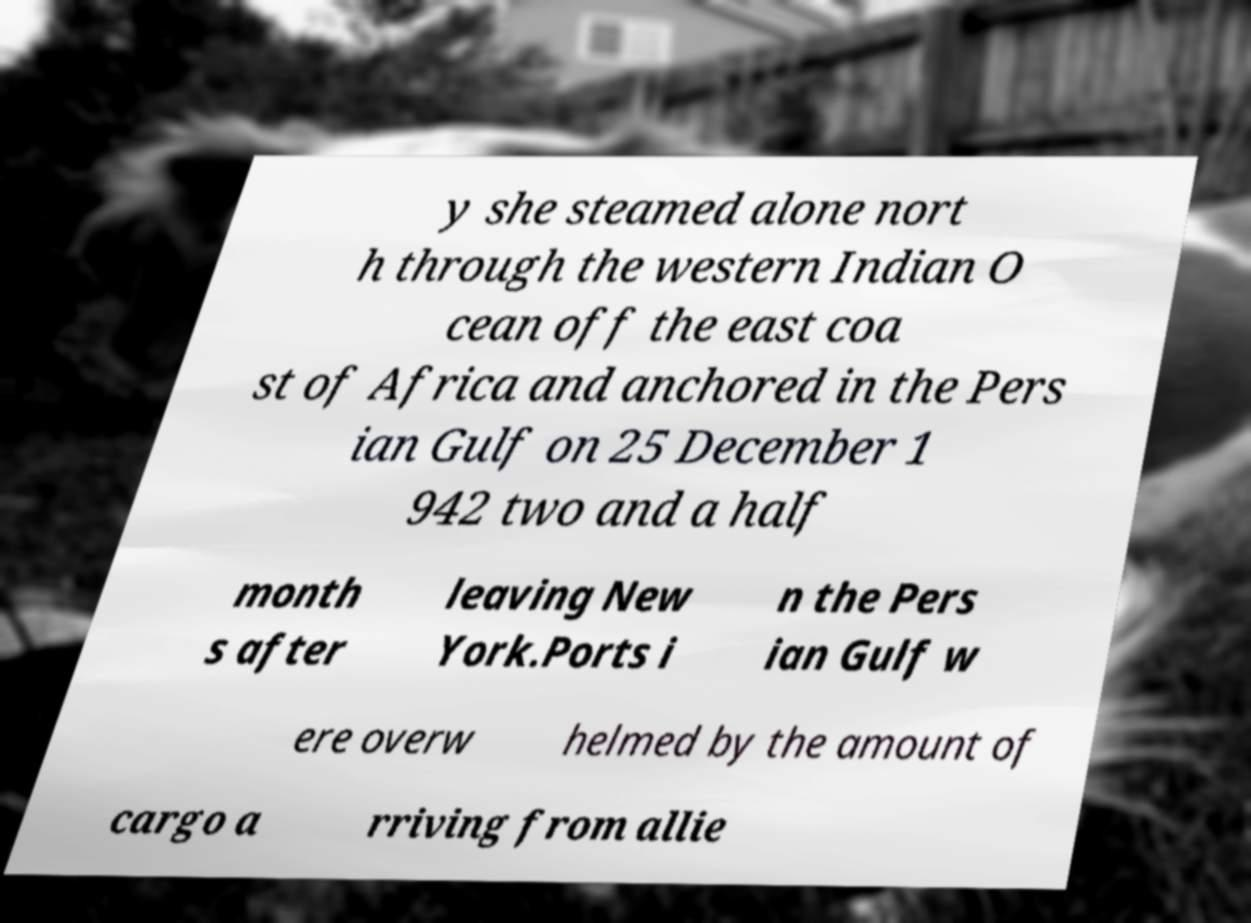Can you read and provide the text displayed in the image?This photo seems to have some interesting text. Can you extract and type it out for me? y she steamed alone nort h through the western Indian O cean off the east coa st of Africa and anchored in the Pers ian Gulf on 25 December 1 942 two and a half month s after leaving New York.Ports i n the Pers ian Gulf w ere overw helmed by the amount of cargo a rriving from allie 